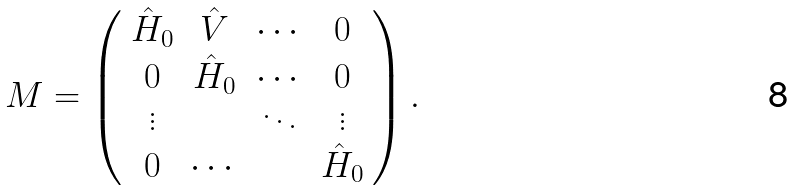<formula> <loc_0><loc_0><loc_500><loc_500>M = \left ( \begin{array} { c c c c } \hat { H } _ { 0 } & \hat { V } & \cdots & 0 \\ 0 & \hat { H } _ { 0 } & \cdots & 0 \\ \vdots & & \ddots & \vdots \\ 0 & \cdots & & \hat { H } _ { 0 } \end{array} \right ) .</formula> 